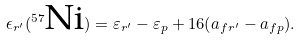Convert formula to latex. <formula><loc_0><loc_0><loc_500><loc_500>\epsilon _ { r ^ { \prime } } ( ^ { 5 7 } \text {Ni} ) = \varepsilon _ { r ^ { \prime } } - \varepsilon _ { p } + 1 6 ( a _ { f r ^ { \prime } } - a _ { f p } ) .</formula> 